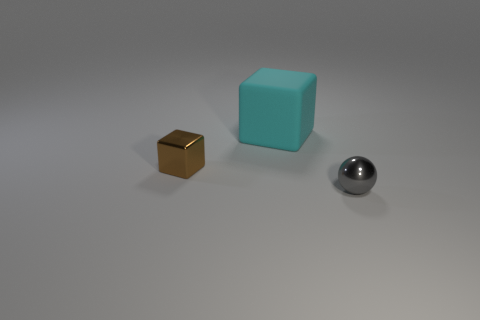Add 1 small spheres. How many objects exist? 4 Subtract all balls. How many objects are left? 2 Add 2 cyan objects. How many cyan objects are left? 3 Add 3 cubes. How many cubes exist? 5 Subtract 0 yellow spheres. How many objects are left? 3 Subtract all tiny brown metal objects. Subtract all small red shiny cylinders. How many objects are left? 2 